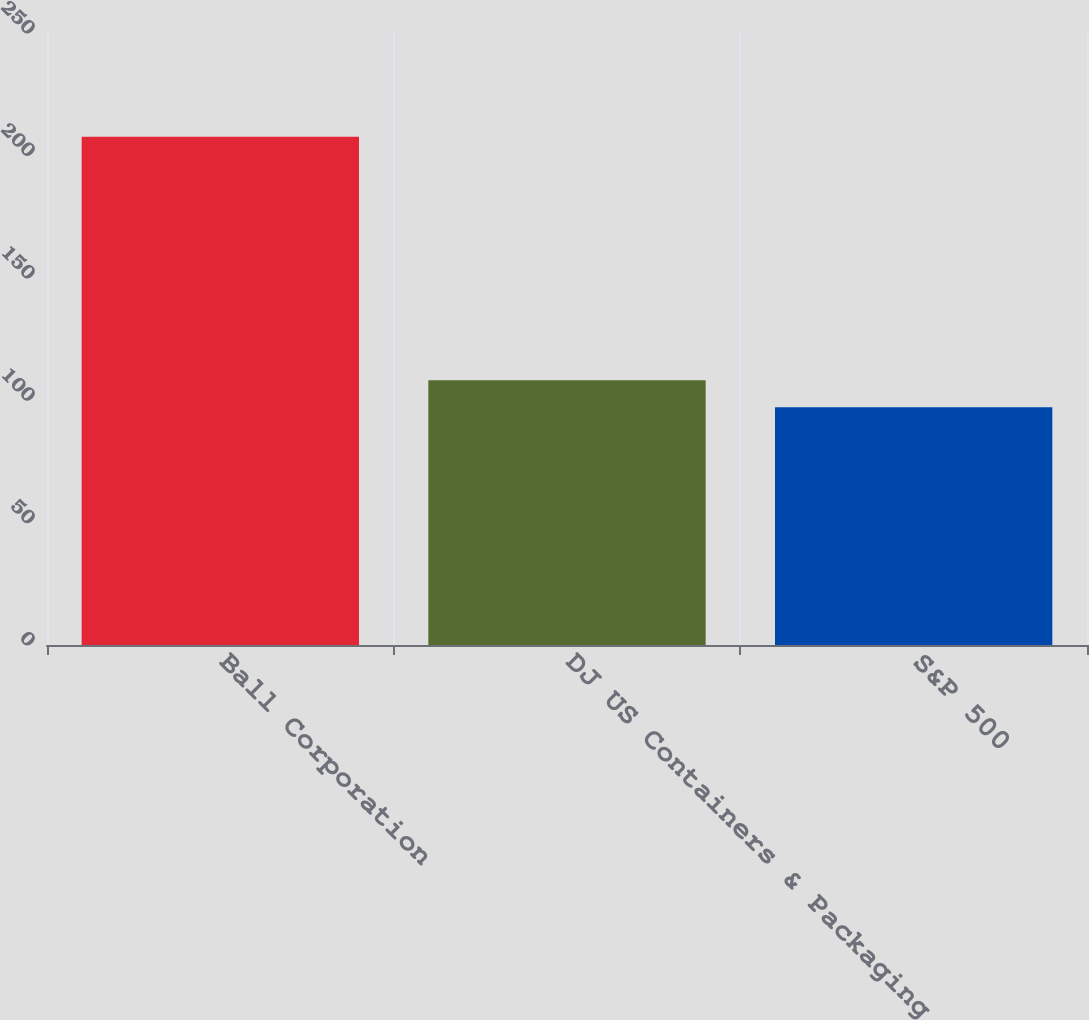<chart> <loc_0><loc_0><loc_500><loc_500><bar_chart><fcel>Ball Corporation<fcel>DJ US Containers & Packaging<fcel>S&P 500<nl><fcel>207.62<fcel>108.18<fcel>97.13<nl></chart> 